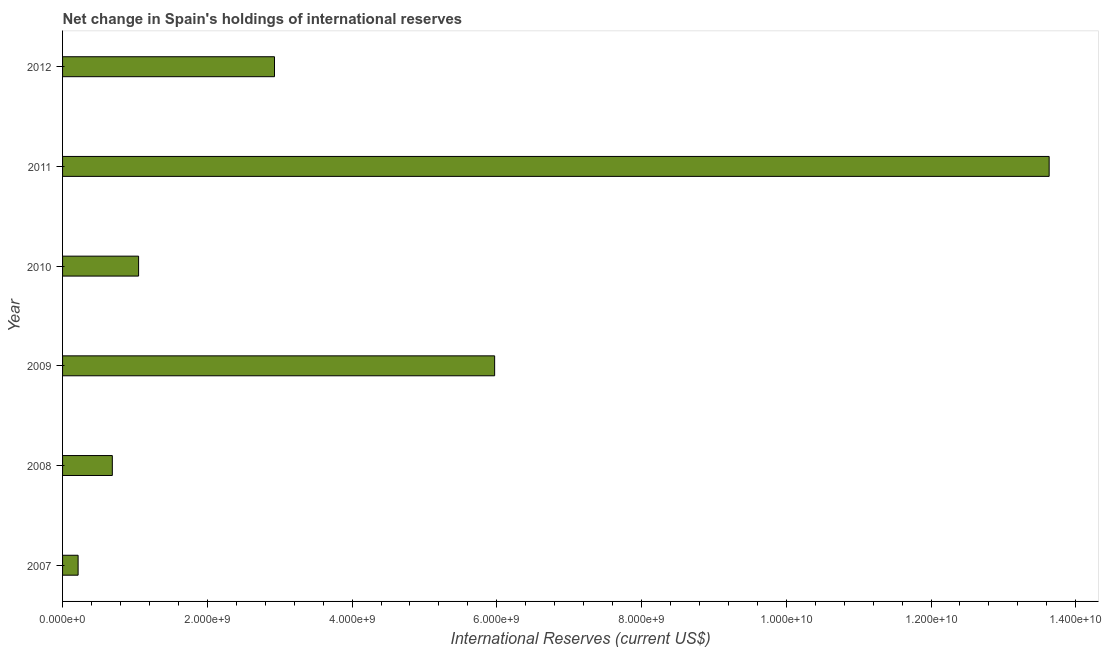Does the graph contain grids?
Your response must be concise. No. What is the title of the graph?
Ensure brevity in your answer.  Net change in Spain's holdings of international reserves. What is the label or title of the X-axis?
Give a very brief answer. International Reserves (current US$). What is the label or title of the Y-axis?
Make the answer very short. Year. What is the reserves and related items in 2007?
Give a very brief answer. 2.15e+08. Across all years, what is the maximum reserves and related items?
Offer a terse response. 1.36e+1. Across all years, what is the minimum reserves and related items?
Your answer should be very brief. 2.15e+08. What is the sum of the reserves and related items?
Offer a terse response. 2.45e+1. What is the difference between the reserves and related items in 2007 and 2011?
Offer a very short reply. -1.34e+1. What is the average reserves and related items per year?
Give a very brief answer. 4.08e+09. What is the median reserves and related items?
Your answer should be very brief. 1.99e+09. Do a majority of the years between 2011 and 2007 (inclusive) have reserves and related items greater than 11200000000 US$?
Ensure brevity in your answer.  Yes. What is the ratio of the reserves and related items in 2008 to that in 2011?
Give a very brief answer. 0.05. Is the difference between the reserves and related items in 2008 and 2010 greater than the difference between any two years?
Make the answer very short. No. What is the difference between the highest and the second highest reserves and related items?
Keep it short and to the point. 7.66e+09. What is the difference between the highest and the lowest reserves and related items?
Your response must be concise. 1.34e+1. In how many years, is the reserves and related items greater than the average reserves and related items taken over all years?
Keep it short and to the point. 2. Are all the bars in the graph horizontal?
Your response must be concise. Yes. How many years are there in the graph?
Provide a short and direct response. 6. What is the International Reserves (current US$) in 2007?
Keep it short and to the point. 2.15e+08. What is the International Reserves (current US$) in 2008?
Make the answer very short. 6.88e+08. What is the International Reserves (current US$) in 2009?
Give a very brief answer. 5.97e+09. What is the International Reserves (current US$) in 2010?
Ensure brevity in your answer.  1.05e+09. What is the International Reserves (current US$) of 2011?
Ensure brevity in your answer.  1.36e+1. What is the International Reserves (current US$) in 2012?
Provide a succinct answer. 2.93e+09. What is the difference between the International Reserves (current US$) in 2007 and 2008?
Your answer should be very brief. -4.73e+08. What is the difference between the International Reserves (current US$) in 2007 and 2009?
Keep it short and to the point. -5.76e+09. What is the difference between the International Reserves (current US$) in 2007 and 2010?
Provide a short and direct response. -8.36e+08. What is the difference between the International Reserves (current US$) in 2007 and 2011?
Provide a succinct answer. -1.34e+1. What is the difference between the International Reserves (current US$) in 2007 and 2012?
Your answer should be very brief. -2.71e+09. What is the difference between the International Reserves (current US$) in 2008 and 2009?
Make the answer very short. -5.28e+09. What is the difference between the International Reserves (current US$) in 2008 and 2010?
Your answer should be compact. -3.63e+08. What is the difference between the International Reserves (current US$) in 2008 and 2011?
Your response must be concise. -1.29e+1. What is the difference between the International Reserves (current US$) in 2008 and 2012?
Give a very brief answer. -2.24e+09. What is the difference between the International Reserves (current US$) in 2009 and 2010?
Offer a terse response. 4.92e+09. What is the difference between the International Reserves (current US$) in 2009 and 2011?
Your response must be concise. -7.66e+09. What is the difference between the International Reserves (current US$) in 2009 and 2012?
Ensure brevity in your answer.  3.04e+09. What is the difference between the International Reserves (current US$) in 2010 and 2011?
Provide a short and direct response. -1.26e+1. What is the difference between the International Reserves (current US$) in 2010 and 2012?
Keep it short and to the point. -1.88e+09. What is the difference between the International Reserves (current US$) in 2011 and 2012?
Keep it short and to the point. 1.07e+1. What is the ratio of the International Reserves (current US$) in 2007 to that in 2008?
Make the answer very short. 0.31. What is the ratio of the International Reserves (current US$) in 2007 to that in 2009?
Offer a terse response. 0.04. What is the ratio of the International Reserves (current US$) in 2007 to that in 2010?
Your answer should be compact. 0.2. What is the ratio of the International Reserves (current US$) in 2007 to that in 2011?
Provide a short and direct response. 0.02. What is the ratio of the International Reserves (current US$) in 2007 to that in 2012?
Offer a terse response. 0.07. What is the ratio of the International Reserves (current US$) in 2008 to that in 2009?
Make the answer very short. 0.12. What is the ratio of the International Reserves (current US$) in 2008 to that in 2010?
Offer a very short reply. 0.65. What is the ratio of the International Reserves (current US$) in 2008 to that in 2011?
Offer a very short reply. 0.05. What is the ratio of the International Reserves (current US$) in 2008 to that in 2012?
Give a very brief answer. 0.23. What is the ratio of the International Reserves (current US$) in 2009 to that in 2010?
Your answer should be very brief. 5.68. What is the ratio of the International Reserves (current US$) in 2009 to that in 2011?
Provide a short and direct response. 0.44. What is the ratio of the International Reserves (current US$) in 2009 to that in 2012?
Your response must be concise. 2.04. What is the ratio of the International Reserves (current US$) in 2010 to that in 2011?
Your response must be concise. 0.08. What is the ratio of the International Reserves (current US$) in 2010 to that in 2012?
Make the answer very short. 0.36. What is the ratio of the International Reserves (current US$) in 2011 to that in 2012?
Your response must be concise. 4.66. 